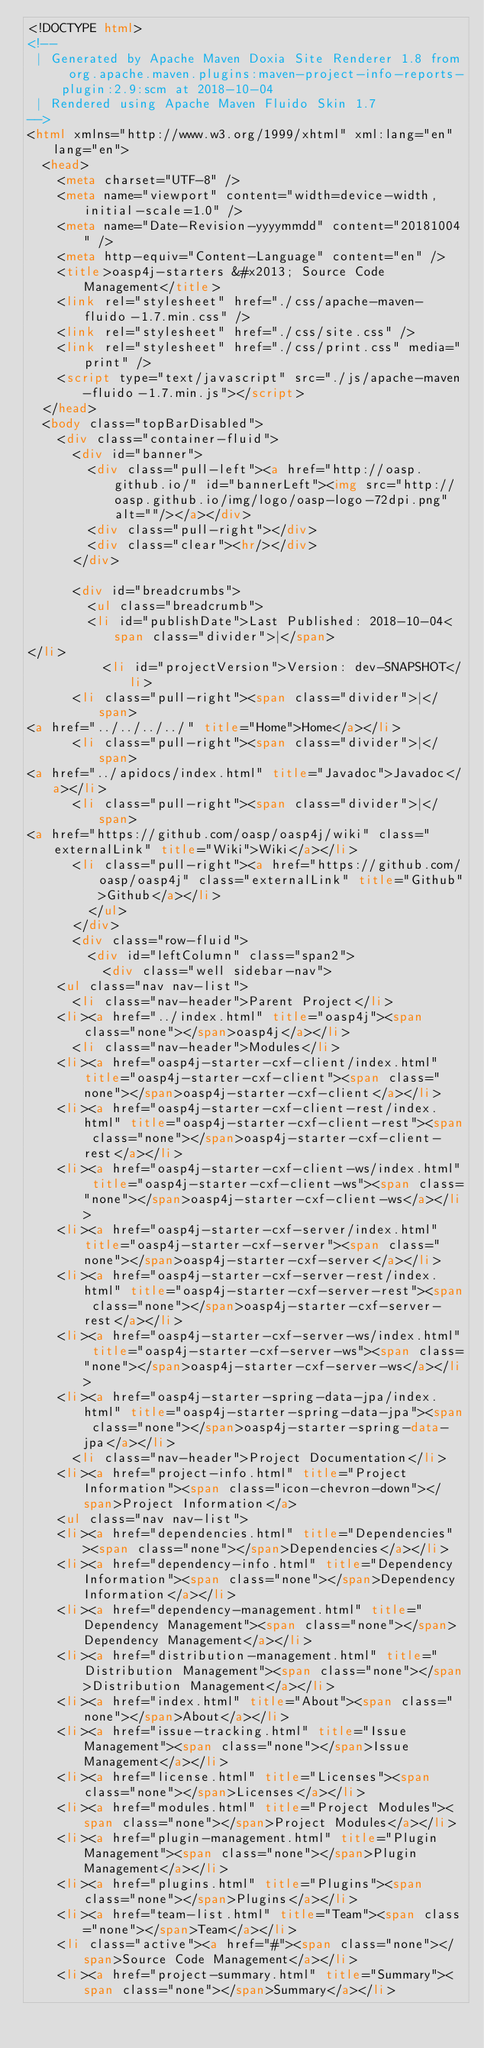Convert code to text. <code><loc_0><loc_0><loc_500><loc_500><_HTML_><!DOCTYPE html>
<!--
 | Generated by Apache Maven Doxia Site Renderer 1.8 from org.apache.maven.plugins:maven-project-info-reports-plugin:2.9:scm at 2018-10-04
 | Rendered using Apache Maven Fluido Skin 1.7
-->
<html xmlns="http://www.w3.org/1999/xhtml" xml:lang="en" lang="en">
  <head>
    <meta charset="UTF-8" />
    <meta name="viewport" content="width=device-width, initial-scale=1.0" />
    <meta name="Date-Revision-yyyymmdd" content="20181004" />
    <meta http-equiv="Content-Language" content="en" />
    <title>oasp4j-starters &#x2013; Source Code Management</title>
    <link rel="stylesheet" href="./css/apache-maven-fluido-1.7.min.css" />
    <link rel="stylesheet" href="./css/site.css" />
    <link rel="stylesheet" href="./css/print.css" media="print" />
    <script type="text/javascript" src="./js/apache-maven-fluido-1.7.min.js"></script>
  </head>
  <body class="topBarDisabled">
    <div class="container-fluid">
      <div id="banner">
        <div class="pull-left"><a href="http://oasp.github.io/" id="bannerLeft"><img src="http://oasp.github.io/img/logo/oasp-logo-72dpi.png"  alt=""/></a></div>
        <div class="pull-right"></div>
        <div class="clear"><hr/></div>
      </div>

      <div id="breadcrumbs">
        <ul class="breadcrumb">
        <li id="publishDate">Last Published: 2018-10-04<span class="divider">|</span>
</li>
          <li id="projectVersion">Version: dev-SNAPSHOT</li>
      <li class="pull-right"><span class="divider">|</span>
<a href="../../../../" title="Home">Home</a></li>
      <li class="pull-right"><span class="divider">|</span>
<a href="../apidocs/index.html" title="Javadoc">Javadoc</a></li>
      <li class="pull-right"><span class="divider">|</span>
<a href="https://github.com/oasp/oasp4j/wiki" class="externalLink" title="Wiki">Wiki</a></li>
      <li class="pull-right"><a href="https://github.com/oasp/oasp4j" class="externalLink" title="Github">Github</a></li>
        </ul>
      </div>
      <div class="row-fluid">
        <div id="leftColumn" class="span2">
          <div class="well sidebar-nav">
    <ul class="nav nav-list">
      <li class="nav-header">Parent Project</li>
    <li><a href="../index.html" title="oasp4j"><span class="none"></span>oasp4j</a></li>
      <li class="nav-header">Modules</li>
    <li><a href="oasp4j-starter-cxf-client/index.html" title="oasp4j-starter-cxf-client"><span class="none"></span>oasp4j-starter-cxf-client</a></li>
    <li><a href="oasp4j-starter-cxf-client-rest/index.html" title="oasp4j-starter-cxf-client-rest"><span class="none"></span>oasp4j-starter-cxf-client-rest</a></li>
    <li><a href="oasp4j-starter-cxf-client-ws/index.html" title="oasp4j-starter-cxf-client-ws"><span class="none"></span>oasp4j-starter-cxf-client-ws</a></li>
    <li><a href="oasp4j-starter-cxf-server/index.html" title="oasp4j-starter-cxf-server"><span class="none"></span>oasp4j-starter-cxf-server</a></li>
    <li><a href="oasp4j-starter-cxf-server-rest/index.html" title="oasp4j-starter-cxf-server-rest"><span class="none"></span>oasp4j-starter-cxf-server-rest</a></li>
    <li><a href="oasp4j-starter-cxf-server-ws/index.html" title="oasp4j-starter-cxf-server-ws"><span class="none"></span>oasp4j-starter-cxf-server-ws</a></li>
    <li><a href="oasp4j-starter-spring-data-jpa/index.html" title="oasp4j-starter-spring-data-jpa"><span class="none"></span>oasp4j-starter-spring-data-jpa</a></li>
      <li class="nav-header">Project Documentation</li>
    <li><a href="project-info.html" title="Project Information"><span class="icon-chevron-down"></span>Project Information</a>
    <ul class="nav nav-list">
    <li><a href="dependencies.html" title="Dependencies"><span class="none"></span>Dependencies</a></li>
    <li><a href="dependency-info.html" title="Dependency Information"><span class="none"></span>Dependency Information</a></li>
    <li><a href="dependency-management.html" title="Dependency Management"><span class="none"></span>Dependency Management</a></li>
    <li><a href="distribution-management.html" title="Distribution Management"><span class="none"></span>Distribution Management</a></li>
    <li><a href="index.html" title="About"><span class="none"></span>About</a></li>
    <li><a href="issue-tracking.html" title="Issue Management"><span class="none"></span>Issue Management</a></li>
    <li><a href="license.html" title="Licenses"><span class="none"></span>Licenses</a></li>
    <li><a href="modules.html" title="Project Modules"><span class="none"></span>Project Modules</a></li>
    <li><a href="plugin-management.html" title="Plugin Management"><span class="none"></span>Plugin Management</a></li>
    <li><a href="plugins.html" title="Plugins"><span class="none"></span>Plugins</a></li>
    <li><a href="team-list.html" title="Team"><span class="none"></span>Team</a></li>
    <li class="active"><a href="#"><span class="none"></span>Source Code Management</a></li>
    <li><a href="project-summary.html" title="Summary"><span class="none"></span>Summary</a></li></code> 